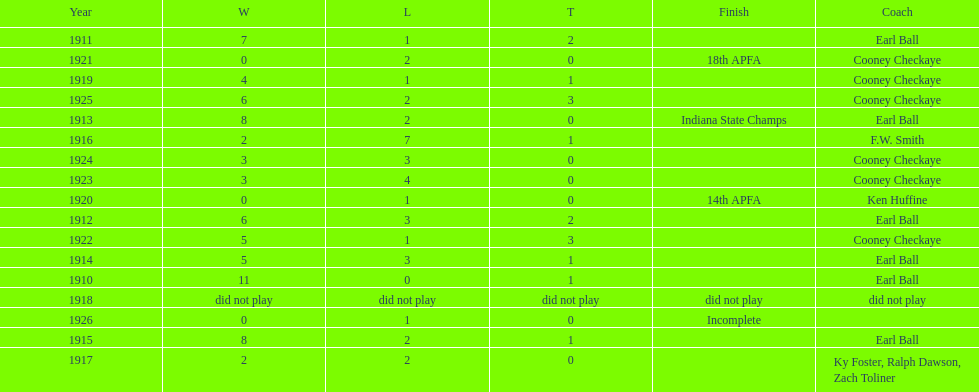The muncie flyers played from 1910 to 1925 in all but one of those years. which year did the flyers not play? 1918. 